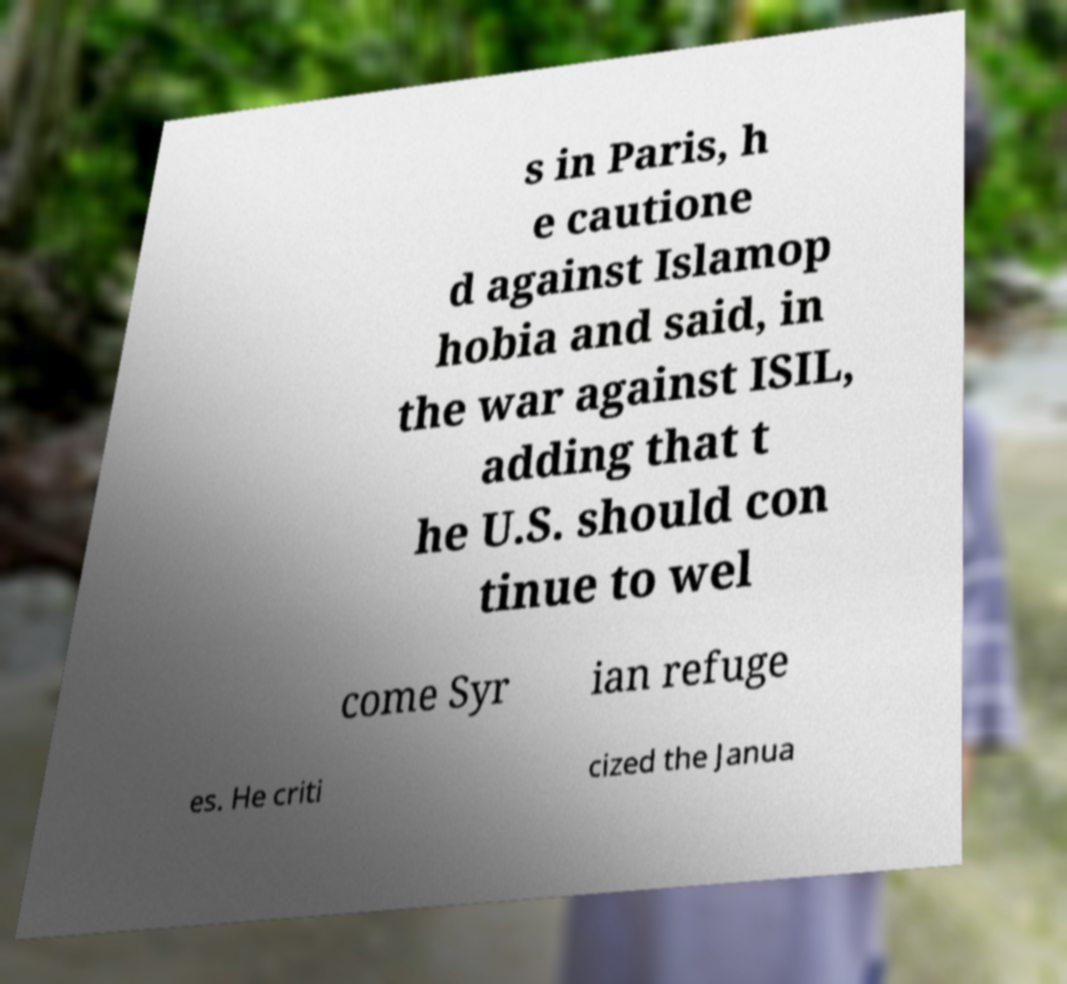I need the written content from this picture converted into text. Can you do that? s in Paris, h e cautione d against Islamop hobia and said, in the war against ISIL, adding that t he U.S. should con tinue to wel come Syr ian refuge es. He criti cized the Janua 